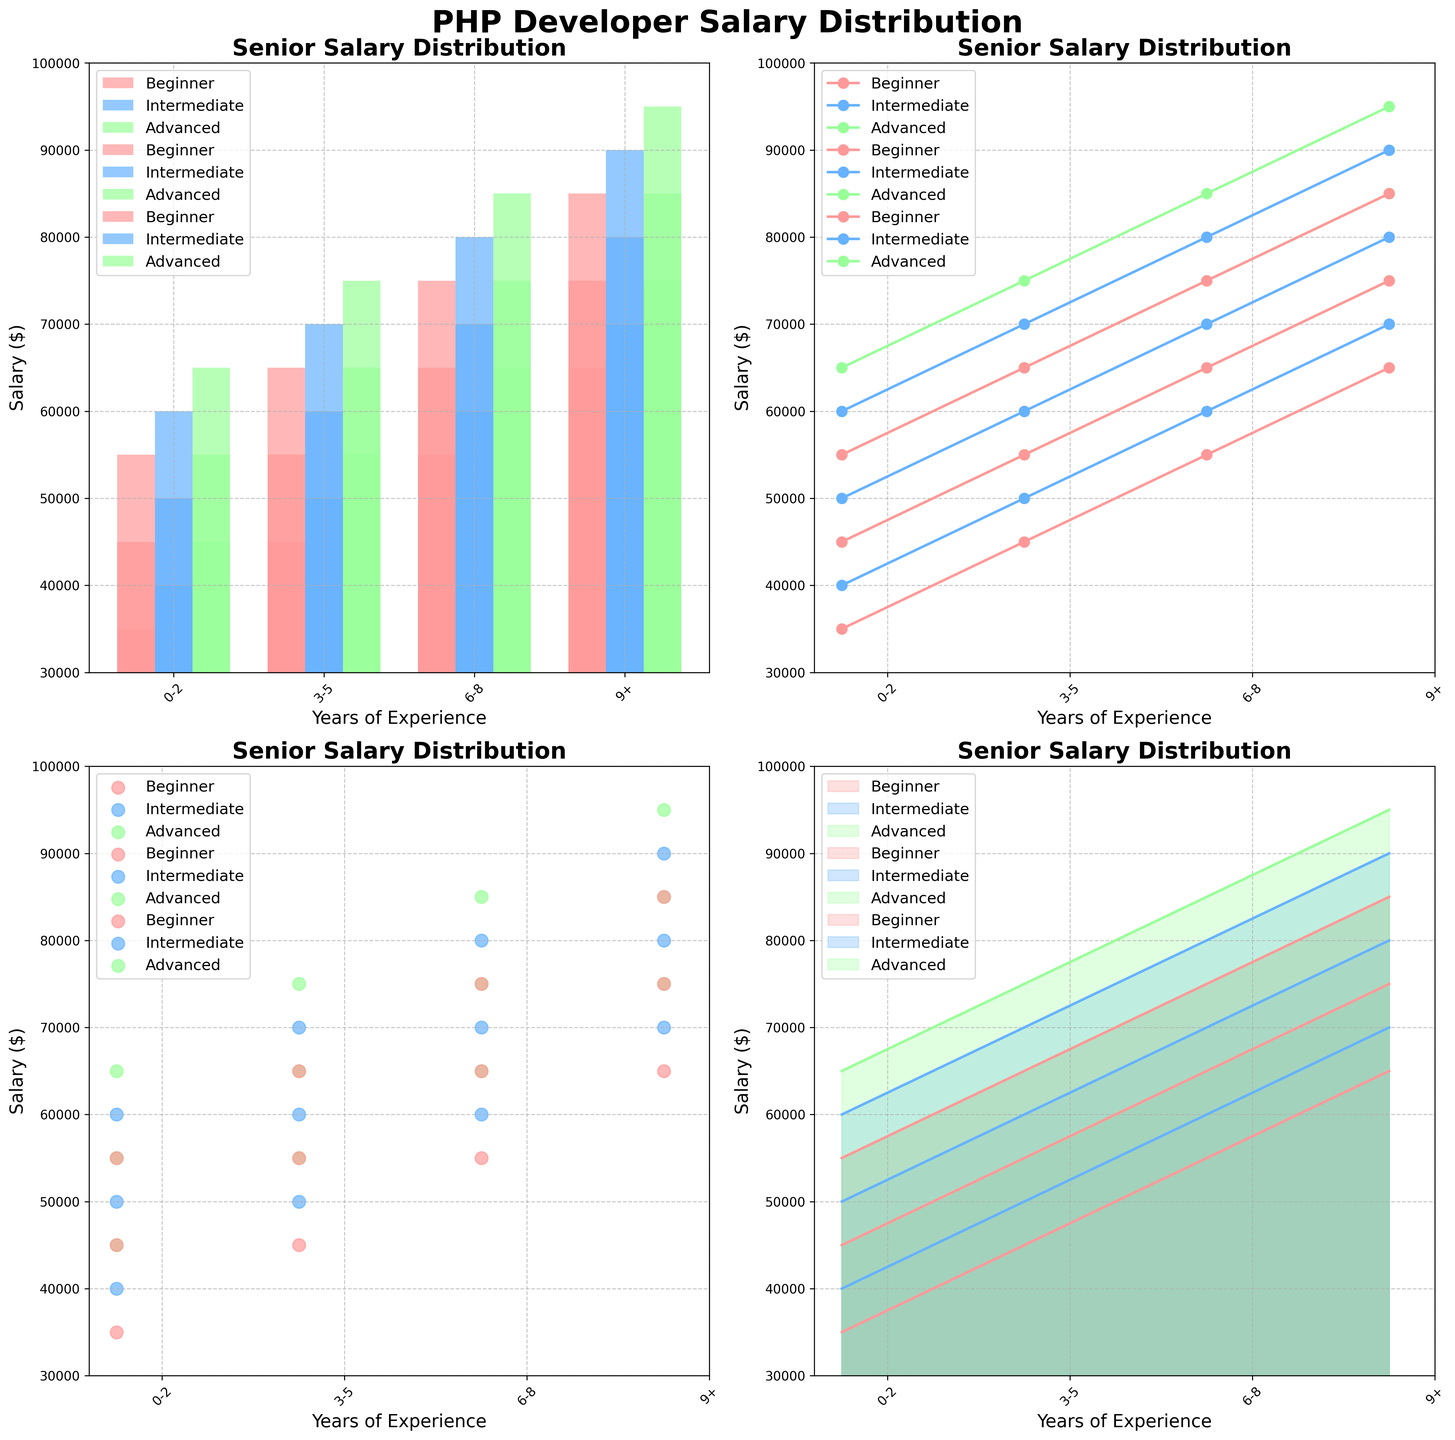How many different OOP expertise levels are represented in the bar plots? The bar plots show different colors and labels for each OOP expertise level. By counting the unique categories, we see they are "Beginner," "Intermediate," and "Advanced."
Answer: 3 Which salary type has the highest maximum value in the line plots? By examining the line plots, we observe that the highest value is seen in the Senior Salary plot at the 9+ years of experience level with an OOP expertise of "Advanced" at $95,000.
Answer: Senior Salary In the scatter plots, which experience level consistently shows the highest salary values for "Intermediate" OOP expertise? By looking at the scatter plots for the "Intermediate" OOP expertise, we see that the 9+ years of experience level has the highest salary values compared to other experience levels.
Answer: 9+ years Is there any chart type where salaries do not increase consistently with years of experience for any OOP expertise level? In the area plots, the filled areas and lines represent salaries for different experience levels and OOP expertise. There is no instance where salaries do not increase with years of experience; all curves show a consistent upward trend.
Answer: No What is the entry-level salary for PHP developers with 3-5 years of experience and "Advanced" OOP expertise in the bar plots? In the bar plots, for the "Advanced" OOP expertise group and 3-5 years of experience, find the bar for the "Entry-Level Salary." It is at $55,000.
Answer: $55,000 Which experience level has the smallest range between entry-level and senior salaries for "Beginner" OOP expertise in the area plots? In the area plots for "Beginner" OOP expertise, the total range is smallest for the 0-2 years of experience level (from $35,000 to $55,000, a range of $20,000).
Answer: 0-2 years On the line plots, how much does the mid-level salary increase from the "Beginner" to "Advanced" OOP expertise for developers with 6-8 years of experience? On the line plots for mid-level salaries, find the increase from "Beginner" ($65,000) to "Advanced" ($75,000) for developers with 6-8 years of experience: $75,000 - $65,000 = $10,000.
Answer: $10,000 In the scatter plots, which experience level shows the largest difference in senior salaries between "Beginner" and "Advanced" OOP expertise levels? The senior salary scatter plots show the largest difference at 9+ years of experience: $95,000 (Advanced) - $85,000 (Beginner) = $10,000 difference.
Answer: 9+ years Compare the trend of mid-level salaries across different OOP expertise levels in the line plots. Which expertise level shows the fastest salary growth with increasing experience? In the line plot for mid-level salaries, observe the slopes of each line. "Advanced" OOP expertise shows the steepest slope, indicating the fastest salary growth with increasing experience.
Answer: Advanced 